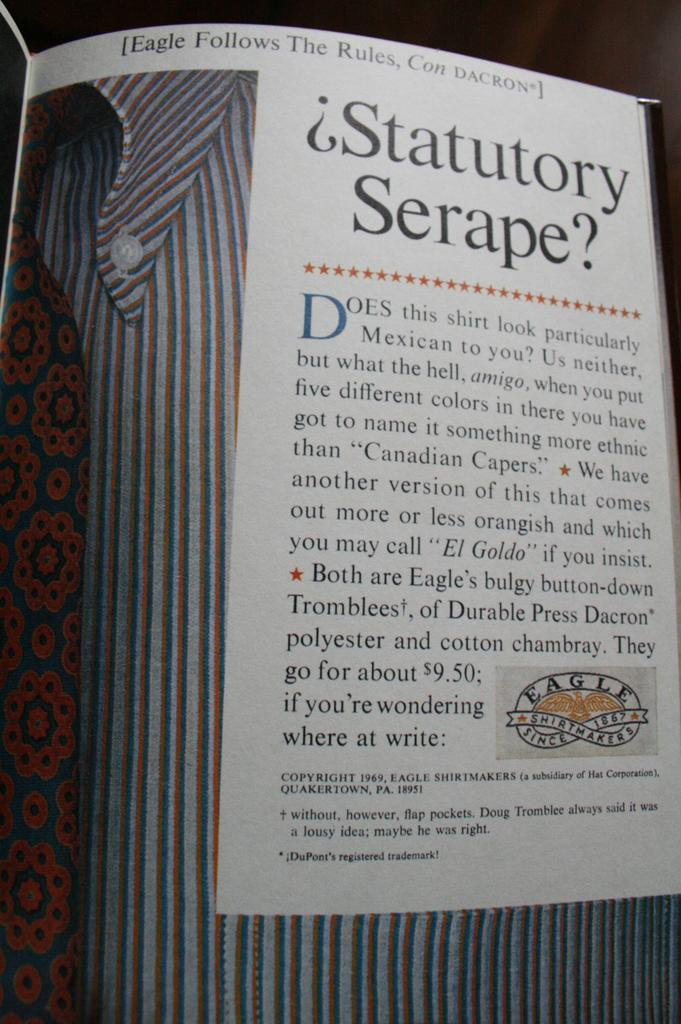<image>
Offer a succinct explanation of the picture presented. A book is open that says Eagle Follows The Rules. 